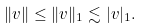<formula> <loc_0><loc_0><loc_500><loc_500>\| v \| \leq \| v \| _ { 1 } \lesssim | v | _ { 1 } .</formula> 